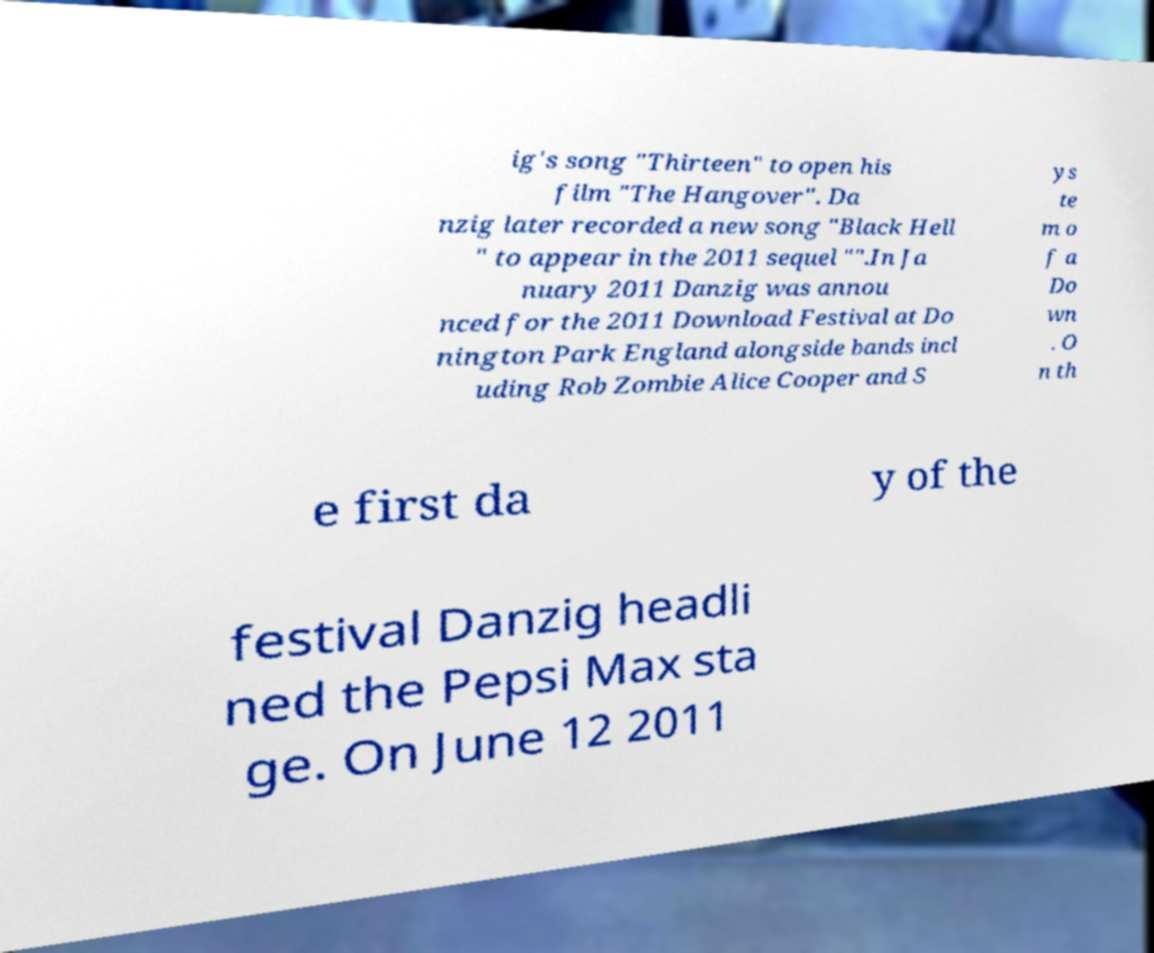I need the written content from this picture converted into text. Can you do that? ig's song "Thirteen" to open his film "The Hangover". Da nzig later recorded a new song "Black Hell " to appear in the 2011 sequel "".In Ja nuary 2011 Danzig was annou nced for the 2011 Download Festival at Do nington Park England alongside bands incl uding Rob Zombie Alice Cooper and S ys te m o f a Do wn . O n th e first da y of the festival Danzig headli ned the Pepsi Max sta ge. On June 12 2011 